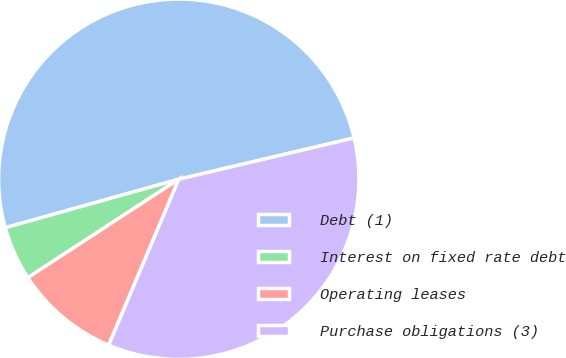Convert chart. <chart><loc_0><loc_0><loc_500><loc_500><pie_chart><fcel>Debt (1)<fcel>Interest on fixed rate debt<fcel>Operating leases<fcel>Purchase obligations (3)<nl><fcel>50.66%<fcel>4.86%<fcel>9.44%<fcel>35.05%<nl></chart> 